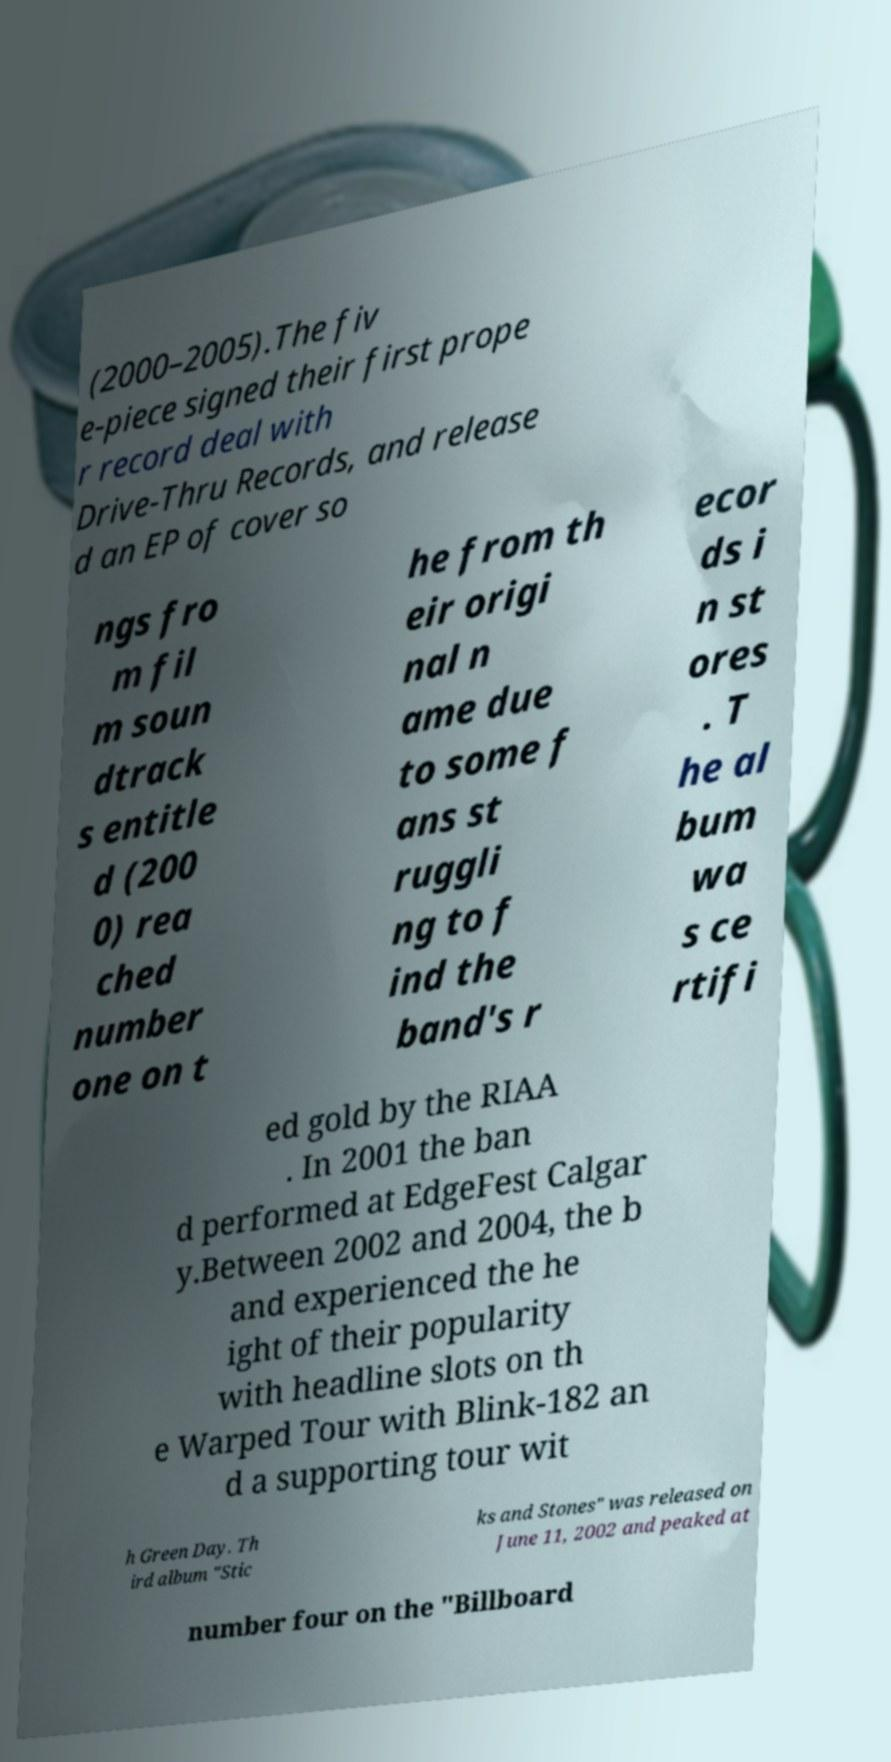Could you assist in decoding the text presented in this image and type it out clearly? (2000–2005).The fiv e-piece signed their first prope r record deal with Drive-Thru Records, and release d an EP of cover so ngs fro m fil m soun dtrack s entitle d (200 0) rea ched number one on t he from th eir origi nal n ame due to some f ans st ruggli ng to f ind the band's r ecor ds i n st ores . T he al bum wa s ce rtifi ed gold by the RIAA . In 2001 the ban d performed at EdgeFest Calgar y.Between 2002 and 2004, the b and experienced the he ight of their popularity with headline slots on th e Warped Tour with Blink-182 an d a supporting tour wit h Green Day. Th ird album "Stic ks and Stones" was released on June 11, 2002 and peaked at number four on the "Billboard 